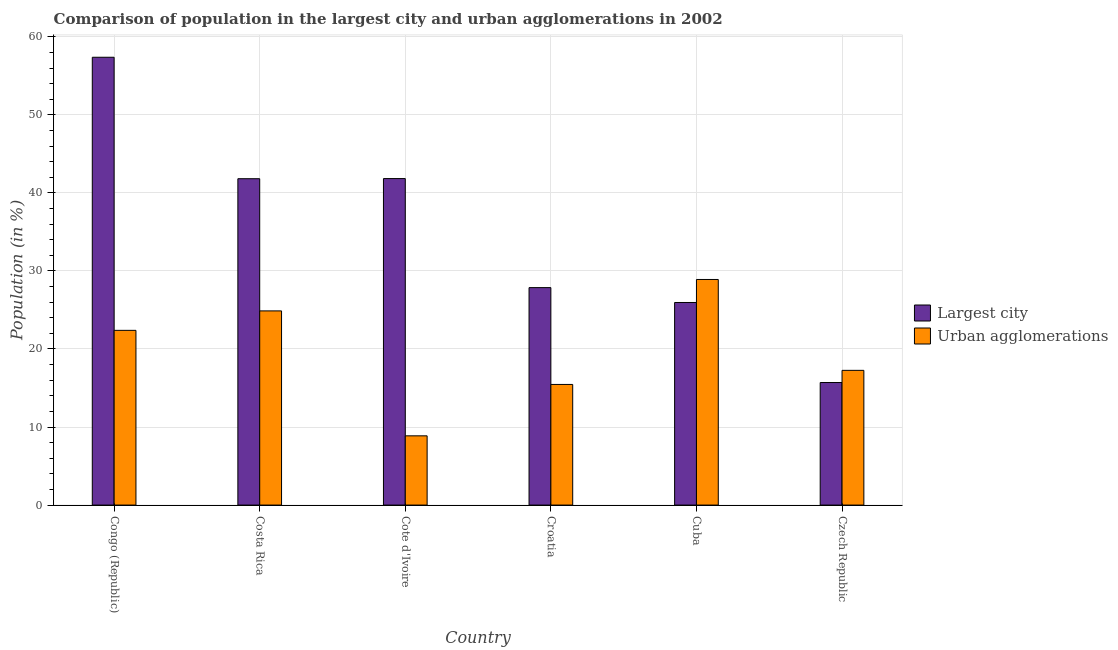How many different coloured bars are there?
Give a very brief answer. 2. How many groups of bars are there?
Your answer should be compact. 6. Are the number of bars per tick equal to the number of legend labels?
Keep it short and to the point. Yes. How many bars are there on the 5th tick from the left?
Offer a very short reply. 2. What is the label of the 3rd group of bars from the left?
Provide a short and direct response. Cote d'Ivoire. What is the population in the largest city in Czech Republic?
Offer a terse response. 15.7. Across all countries, what is the maximum population in the largest city?
Keep it short and to the point. 57.38. Across all countries, what is the minimum population in the largest city?
Give a very brief answer. 15.7. In which country was the population in urban agglomerations maximum?
Your response must be concise. Cuba. In which country was the population in the largest city minimum?
Offer a terse response. Czech Republic. What is the total population in the largest city in the graph?
Give a very brief answer. 210.56. What is the difference between the population in the largest city in Congo (Republic) and that in Croatia?
Your answer should be compact. 29.52. What is the difference between the population in urban agglomerations in Costa Rica and the population in the largest city in Cote d'Ivoire?
Offer a terse response. -16.96. What is the average population in urban agglomerations per country?
Ensure brevity in your answer.  19.63. What is the difference between the population in the largest city and population in urban agglomerations in Costa Rica?
Provide a short and direct response. 16.94. In how many countries, is the population in the largest city greater than 42 %?
Ensure brevity in your answer.  1. What is the ratio of the population in urban agglomerations in Costa Rica to that in Cote d'Ivoire?
Your answer should be compact. 2.8. Is the population in the largest city in Congo (Republic) less than that in Cote d'Ivoire?
Your response must be concise. No. What is the difference between the highest and the second highest population in urban agglomerations?
Your answer should be compact. 4.03. What is the difference between the highest and the lowest population in the largest city?
Offer a very short reply. 41.68. What does the 2nd bar from the left in Congo (Republic) represents?
Your response must be concise. Urban agglomerations. What does the 2nd bar from the right in Czech Republic represents?
Provide a short and direct response. Largest city. Are the values on the major ticks of Y-axis written in scientific E-notation?
Provide a succinct answer. No. Does the graph contain grids?
Make the answer very short. Yes. What is the title of the graph?
Provide a short and direct response. Comparison of population in the largest city and urban agglomerations in 2002. Does "IMF nonconcessional" appear as one of the legend labels in the graph?
Provide a succinct answer. No. What is the Population (in %) of Largest city in Congo (Republic)?
Your answer should be very brief. 57.38. What is the Population (in %) in Urban agglomerations in Congo (Republic)?
Your answer should be very brief. 22.39. What is the Population (in %) of Largest city in Costa Rica?
Your answer should be very brief. 41.82. What is the Population (in %) in Urban agglomerations in Costa Rica?
Give a very brief answer. 24.88. What is the Population (in %) in Largest city in Cote d'Ivoire?
Offer a very short reply. 41.84. What is the Population (in %) of Urban agglomerations in Cote d'Ivoire?
Your response must be concise. 8.87. What is the Population (in %) in Largest city in Croatia?
Offer a terse response. 27.86. What is the Population (in %) in Urban agglomerations in Croatia?
Your answer should be very brief. 15.46. What is the Population (in %) of Largest city in Cuba?
Make the answer very short. 25.96. What is the Population (in %) in Urban agglomerations in Cuba?
Offer a very short reply. 28.91. What is the Population (in %) of Largest city in Czech Republic?
Make the answer very short. 15.7. What is the Population (in %) in Urban agglomerations in Czech Republic?
Your answer should be compact. 17.26. Across all countries, what is the maximum Population (in %) in Largest city?
Make the answer very short. 57.38. Across all countries, what is the maximum Population (in %) of Urban agglomerations?
Offer a terse response. 28.91. Across all countries, what is the minimum Population (in %) of Largest city?
Provide a succinct answer. 15.7. Across all countries, what is the minimum Population (in %) in Urban agglomerations?
Provide a short and direct response. 8.87. What is the total Population (in %) of Largest city in the graph?
Provide a short and direct response. 210.56. What is the total Population (in %) in Urban agglomerations in the graph?
Provide a short and direct response. 117.77. What is the difference between the Population (in %) of Largest city in Congo (Republic) and that in Costa Rica?
Make the answer very short. 15.56. What is the difference between the Population (in %) of Urban agglomerations in Congo (Republic) and that in Costa Rica?
Your response must be concise. -2.49. What is the difference between the Population (in %) in Largest city in Congo (Republic) and that in Cote d'Ivoire?
Give a very brief answer. 15.54. What is the difference between the Population (in %) of Urban agglomerations in Congo (Republic) and that in Cote d'Ivoire?
Provide a short and direct response. 13.52. What is the difference between the Population (in %) of Largest city in Congo (Republic) and that in Croatia?
Your answer should be compact. 29.52. What is the difference between the Population (in %) in Urban agglomerations in Congo (Republic) and that in Croatia?
Make the answer very short. 6.93. What is the difference between the Population (in %) of Largest city in Congo (Republic) and that in Cuba?
Your answer should be compact. 31.42. What is the difference between the Population (in %) in Urban agglomerations in Congo (Republic) and that in Cuba?
Make the answer very short. -6.52. What is the difference between the Population (in %) in Largest city in Congo (Republic) and that in Czech Republic?
Provide a short and direct response. 41.68. What is the difference between the Population (in %) of Urban agglomerations in Congo (Republic) and that in Czech Republic?
Your response must be concise. 5.12. What is the difference between the Population (in %) in Largest city in Costa Rica and that in Cote d'Ivoire?
Keep it short and to the point. -0.02. What is the difference between the Population (in %) in Urban agglomerations in Costa Rica and that in Cote d'Ivoire?
Provide a succinct answer. 16.01. What is the difference between the Population (in %) in Largest city in Costa Rica and that in Croatia?
Provide a short and direct response. 13.95. What is the difference between the Population (in %) in Urban agglomerations in Costa Rica and that in Croatia?
Your answer should be compact. 9.42. What is the difference between the Population (in %) in Largest city in Costa Rica and that in Cuba?
Ensure brevity in your answer.  15.86. What is the difference between the Population (in %) of Urban agglomerations in Costa Rica and that in Cuba?
Your answer should be very brief. -4.03. What is the difference between the Population (in %) of Largest city in Costa Rica and that in Czech Republic?
Give a very brief answer. 26.12. What is the difference between the Population (in %) of Urban agglomerations in Costa Rica and that in Czech Republic?
Give a very brief answer. 7.62. What is the difference between the Population (in %) of Largest city in Cote d'Ivoire and that in Croatia?
Ensure brevity in your answer.  13.97. What is the difference between the Population (in %) of Urban agglomerations in Cote d'Ivoire and that in Croatia?
Your answer should be very brief. -6.58. What is the difference between the Population (in %) in Largest city in Cote d'Ivoire and that in Cuba?
Offer a terse response. 15.88. What is the difference between the Population (in %) of Urban agglomerations in Cote d'Ivoire and that in Cuba?
Your response must be concise. -20.04. What is the difference between the Population (in %) of Largest city in Cote d'Ivoire and that in Czech Republic?
Offer a very short reply. 26.13. What is the difference between the Population (in %) of Urban agglomerations in Cote d'Ivoire and that in Czech Republic?
Provide a succinct answer. -8.39. What is the difference between the Population (in %) of Largest city in Croatia and that in Cuba?
Provide a short and direct response. 1.91. What is the difference between the Population (in %) in Urban agglomerations in Croatia and that in Cuba?
Make the answer very short. -13.45. What is the difference between the Population (in %) of Largest city in Croatia and that in Czech Republic?
Offer a terse response. 12.16. What is the difference between the Population (in %) in Urban agglomerations in Croatia and that in Czech Republic?
Your response must be concise. -1.81. What is the difference between the Population (in %) of Largest city in Cuba and that in Czech Republic?
Offer a terse response. 10.26. What is the difference between the Population (in %) in Urban agglomerations in Cuba and that in Czech Republic?
Provide a succinct answer. 11.64. What is the difference between the Population (in %) of Largest city in Congo (Republic) and the Population (in %) of Urban agglomerations in Costa Rica?
Provide a succinct answer. 32.5. What is the difference between the Population (in %) in Largest city in Congo (Republic) and the Population (in %) in Urban agglomerations in Cote d'Ivoire?
Offer a very short reply. 48.51. What is the difference between the Population (in %) in Largest city in Congo (Republic) and the Population (in %) in Urban agglomerations in Croatia?
Offer a terse response. 41.92. What is the difference between the Population (in %) in Largest city in Congo (Republic) and the Population (in %) in Urban agglomerations in Cuba?
Give a very brief answer. 28.47. What is the difference between the Population (in %) of Largest city in Congo (Republic) and the Population (in %) of Urban agglomerations in Czech Republic?
Your answer should be compact. 40.12. What is the difference between the Population (in %) of Largest city in Costa Rica and the Population (in %) of Urban agglomerations in Cote d'Ivoire?
Your answer should be very brief. 32.95. What is the difference between the Population (in %) of Largest city in Costa Rica and the Population (in %) of Urban agglomerations in Croatia?
Ensure brevity in your answer.  26.36. What is the difference between the Population (in %) in Largest city in Costa Rica and the Population (in %) in Urban agglomerations in Cuba?
Make the answer very short. 12.91. What is the difference between the Population (in %) of Largest city in Costa Rica and the Population (in %) of Urban agglomerations in Czech Republic?
Give a very brief answer. 24.56. What is the difference between the Population (in %) in Largest city in Cote d'Ivoire and the Population (in %) in Urban agglomerations in Croatia?
Your response must be concise. 26.38. What is the difference between the Population (in %) of Largest city in Cote d'Ivoire and the Population (in %) of Urban agglomerations in Cuba?
Offer a very short reply. 12.93. What is the difference between the Population (in %) in Largest city in Cote d'Ivoire and the Population (in %) in Urban agglomerations in Czech Republic?
Ensure brevity in your answer.  24.57. What is the difference between the Population (in %) of Largest city in Croatia and the Population (in %) of Urban agglomerations in Cuba?
Make the answer very short. -1.04. What is the difference between the Population (in %) in Largest city in Croatia and the Population (in %) in Urban agglomerations in Czech Republic?
Provide a short and direct response. 10.6. What is the difference between the Population (in %) of Largest city in Cuba and the Population (in %) of Urban agglomerations in Czech Republic?
Make the answer very short. 8.7. What is the average Population (in %) in Largest city per country?
Provide a short and direct response. 35.09. What is the average Population (in %) in Urban agglomerations per country?
Make the answer very short. 19.63. What is the difference between the Population (in %) in Largest city and Population (in %) in Urban agglomerations in Congo (Republic)?
Ensure brevity in your answer.  34.99. What is the difference between the Population (in %) in Largest city and Population (in %) in Urban agglomerations in Costa Rica?
Provide a succinct answer. 16.94. What is the difference between the Population (in %) in Largest city and Population (in %) in Urban agglomerations in Cote d'Ivoire?
Your answer should be very brief. 32.96. What is the difference between the Population (in %) of Largest city and Population (in %) of Urban agglomerations in Croatia?
Offer a terse response. 12.41. What is the difference between the Population (in %) of Largest city and Population (in %) of Urban agglomerations in Cuba?
Provide a succinct answer. -2.95. What is the difference between the Population (in %) in Largest city and Population (in %) in Urban agglomerations in Czech Republic?
Provide a short and direct response. -1.56. What is the ratio of the Population (in %) of Largest city in Congo (Republic) to that in Costa Rica?
Give a very brief answer. 1.37. What is the ratio of the Population (in %) in Urban agglomerations in Congo (Republic) to that in Costa Rica?
Make the answer very short. 0.9. What is the ratio of the Population (in %) of Largest city in Congo (Republic) to that in Cote d'Ivoire?
Your answer should be very brief. 1.37. What is the ratio of the Population (in %) in Urban agglomerations in Congo (Republic) to that in Cote d'Ivoire?
Your answer should be very brief. 2.52. What is the ratio of the Population (in %) of Largest city in Congo (Republic) to that in Croatia?
Offer a very short reply. 2.06. What is the ratio of the Population (in %) of Urban agglomerations in Congo (Republic) to that in Croatia?
Give a very brief answer. 1.45. What is the ratio of the Population (in %) in Largest city in Congo (Republic) to that in Cuba?
Give a very brief answer. 2.21. What is the ratio of the Population (in %) of Urban agglomerations in Congo (Republic) to that in Cuba?
Keep it short and to the point. 0.77. What is the ratio of the Population (in %) of Largest city in Congo (Republic) to that in Czech Republic?
Give a very brief answer. 3.65. What is the ratio of the Population (in %) of Urban agglomerations in Congo (Republic) to that in Czech Republic?
Provide a succinct answer. 1.3. What is the ratio of the Population (in %) of Largest city in Costa Rica to that in Cote d'Ivoire?
Offer a very short reply. 1. What is the ratio of the Population (in %) in Urban agglomerations in Costa Rica to that in Cote d'Ivoire?
Make the answer very short. 2.8. What is the ratio of the Population (in %) in Largest city in Costa Rica to that in Croatia?
Make the answer very short. 1.5. What is the ratio of the Population (in %) in Urban agglomerations in Costa Rica to that in Croatia?
Your answer should be very brief. 1.61. What is the ratio of the Population (in %) in Largest city in Costa Rica to that in Cuba?
Provide a succinct answer. 1.61. What is the ratio of the Population (in %) in Urban agglomerations in Costa Rica to that in Cuba?
Provide a succinct answer. 0.86. What is the ratio of the Population (in %) in Largest city in Costa Rica to that in Czech Republic?
Provide a short and direct response. 2.66. What is the ratio of the Population (in %) in Urban agglomerations in Costa Rica to that in Czech Republic?
Your response must be concise. 1.44. What is the ratio of the Population (in %) in Largest city in Cote d'Ivoire to that in Croatia?
Make the answer very short. 1.5. What is the ratio of the Population (in %) of Urban agglomerations in Cote d'Ivoire to that in Croatia?
Offer a terse response. 0.57. What is the ratio of the Population (in %) of Largest city in Cote d'Ivoire to that in Cuba?
Your answer should be compact. 1.61. What is the ratio of the Population (in %) of Urban agglomerations in Cote d'Ivoire to that in Cuba?
Your answer should be very brief. 0.31. What is the ratio of the Population (in %) in Largest city in Cote d'Ivoire to that in Czech Republic?
Offer a terse response. 2.66. What is the ratio of the Population (in %) of Urban agglomerations in Cote d'Ivoire to that in Czech Republic?
Give a very brief answer. 0.51. What is the ratio of the Population (in %) of Largest city in Croatia to that in Cuba?
Your response must be concise. 1.07. What is the ratio of the Population (in %) of Urban agglomerations in Croatia to that in Cuba?
Offer a very short reply. 0.53. What is the ratio of the Population (in %) in Largest city in Croatia to that in Czech Republic?
Offer a very short reply. 1.77. What is the ratio of the Population (in %) of Urban agglomerations in Croatia to that in Czech Republic?
Give a very brief answer. 0.9. What is the ratio of the Population (in %) in Largest city in Cuba to that in Czech Republic?
Your answer should be compact. 1.65. What is the ratio of the Population (in %) in Urban agglomerations in Cuba to that in Czech Republic?
Your response must be concise. 1.67. What is the difference between the highest and the second highest Population (in %) in Largest city?
Offer a very short reply. 15.54. What is the difference between the highest and the second highest Population (in %) of Urban agglomerations?
Offer a terse response. 4.03. What is the difference between the highest and the lowest Population (in %) in Largest city?
Your response must be concise. 41.68. What is the difference between the highest and the lowest Population (in %) in Urban agglomerations?
Make the answer very short. 20.04. 